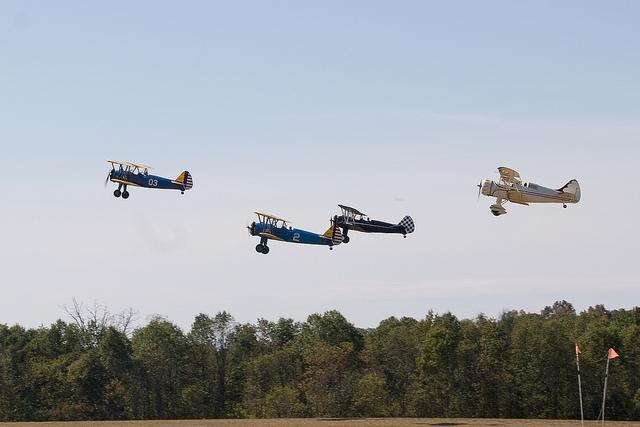How many flags are visible?
Give a very brief answer. 2. 